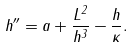Convert formula to latex. <formula><loc_0><loc_0><loc_500><loc_500>h ^ { \prime \prime } = a + \frac { L ^ { 2 } } { h ^ { 3 } } - \frac { h } { \kappa } .</formula> 